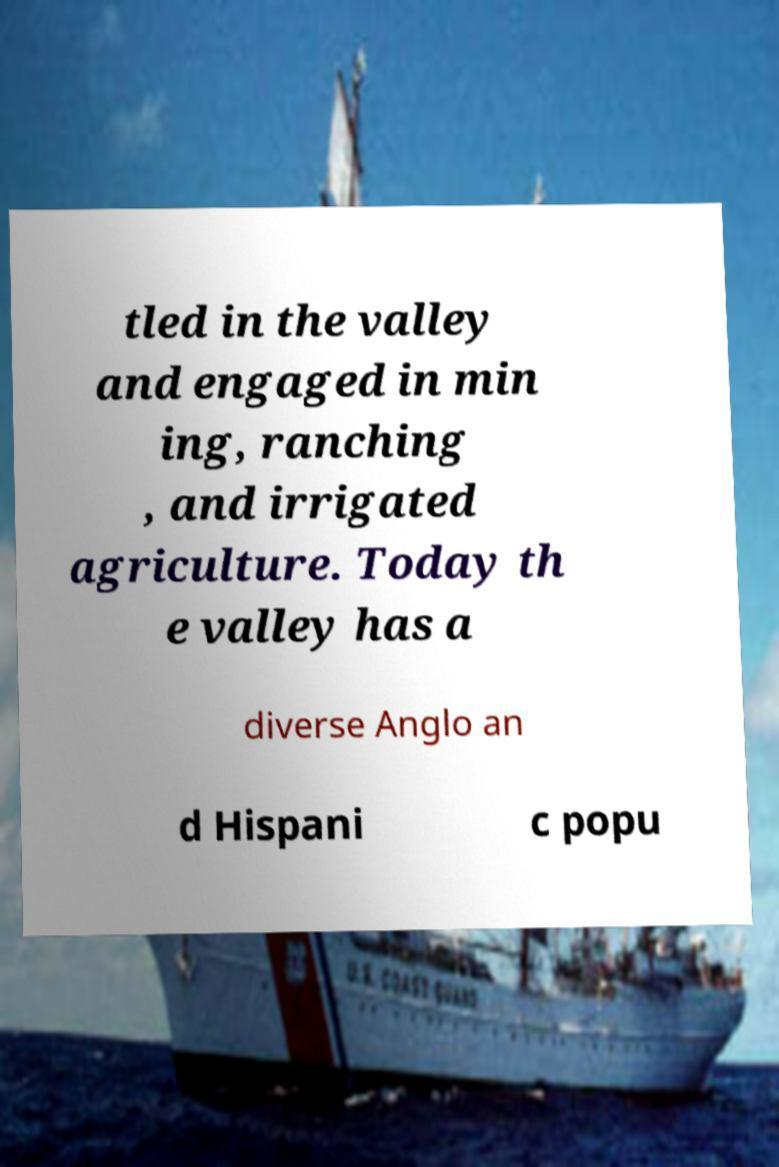There's text embedded in this image that I need extracted. Can you transcribe it verbatim? tled in the valley and engaged in min ing, ranching , and irrigated agriculture. Today th e valley has a diverse Anglo an d Hispani c popu 